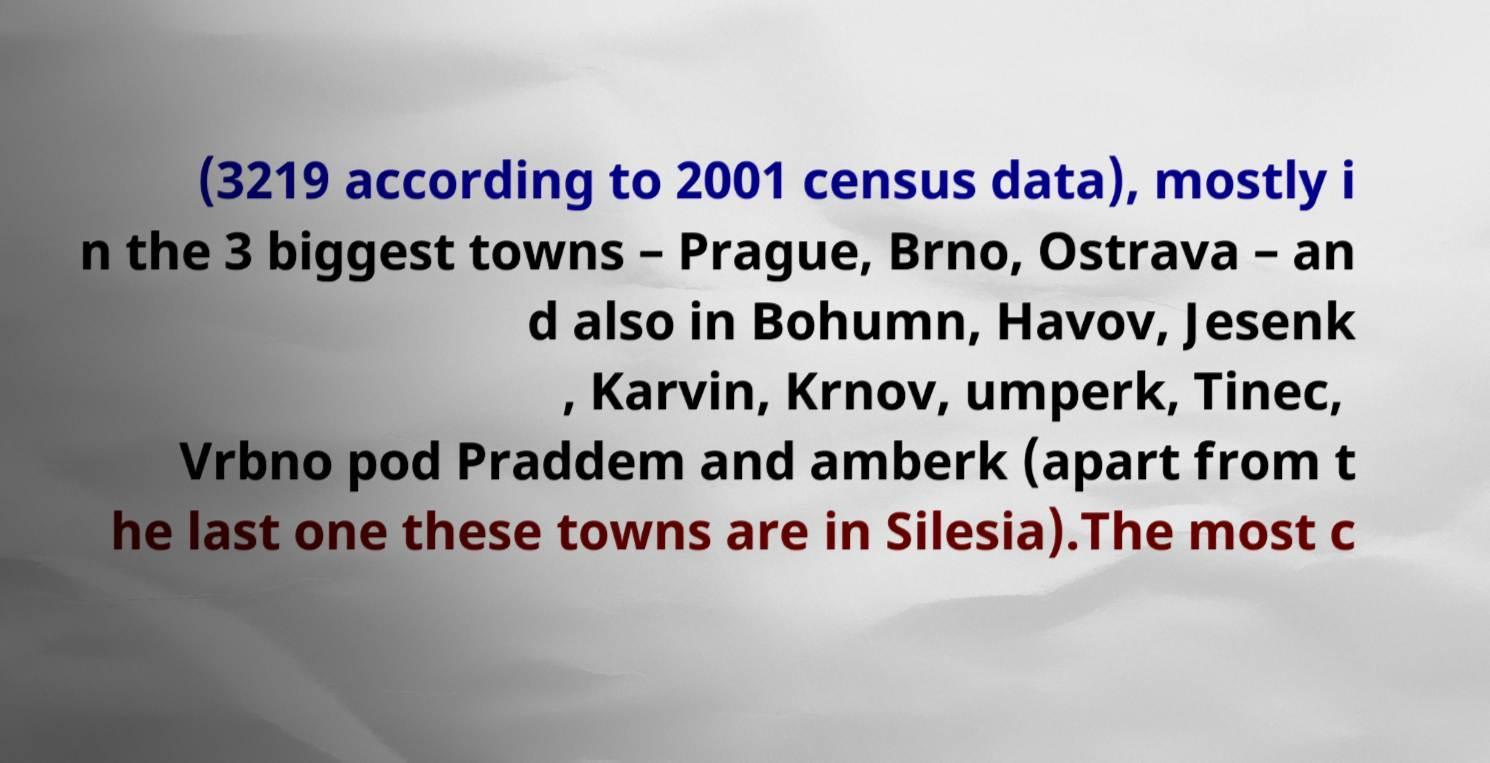For documentation purposes, I need the text within this image transcribed. Could you provide that? (3219 according to 2001 census data), mostly i n the 3 biggest towns – Prague, Brno, Ostrava – an d also in Bohumn, Havov, Jesenk , Karvin, Krnov, umperk, Tinec, Vrbno pod Praddem and amberk (apart from t he last one these towns are in Silesia).The most c 